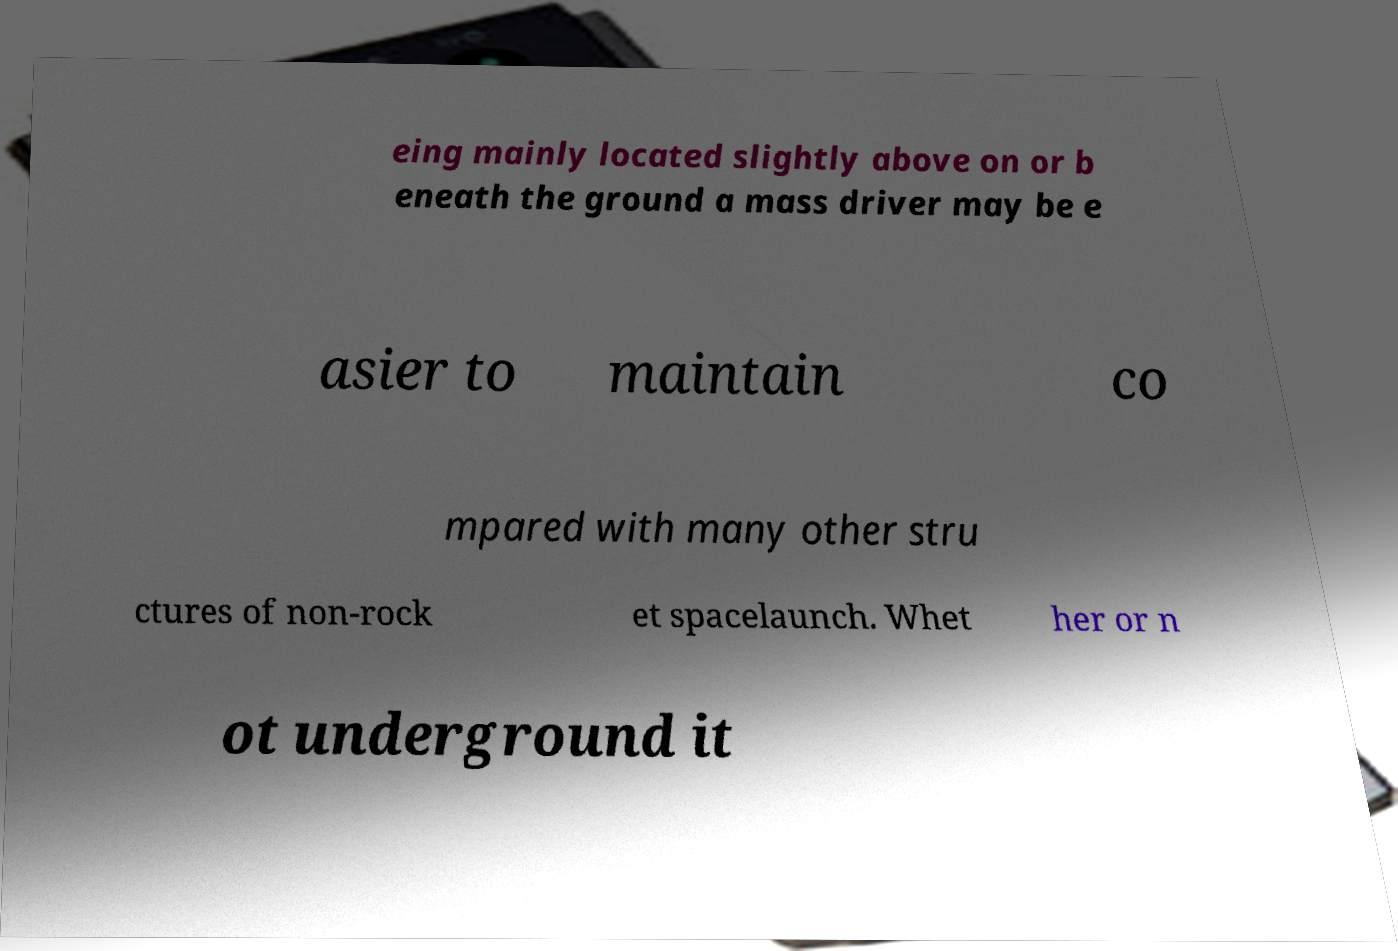Can you accurately transcribe the text from the provided image for me? eing mainly located slightly above on or b eneath the ground a mass driver may be e asier to maintain co mpared with many other stru ctures of non-rock et spacelaunch. Whet her or n ot underground it 